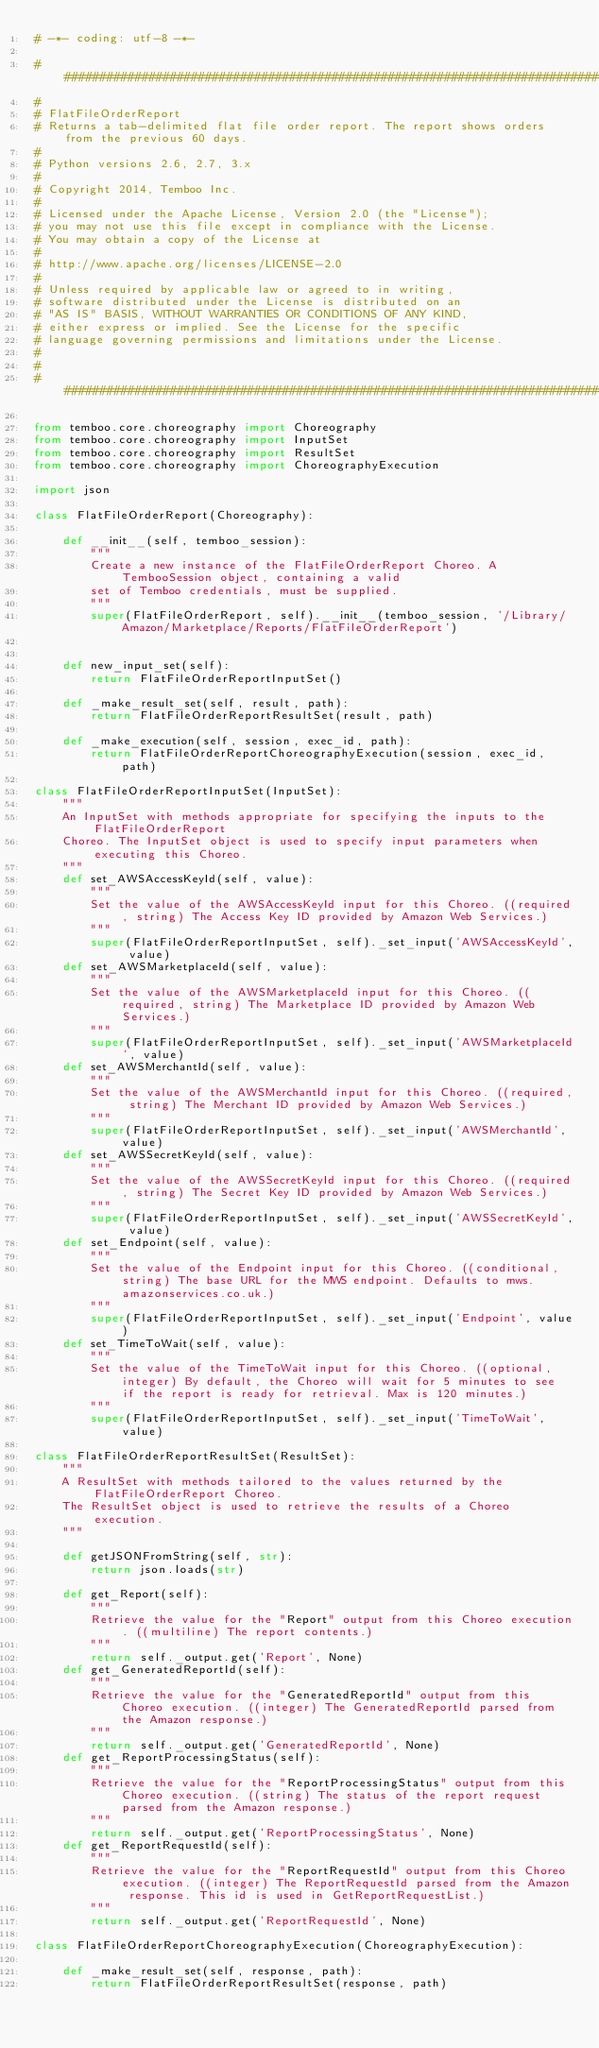Convert code to text. <code><loc_0><loc_0><loc_500><loc_500><_Python_># -*- coding: utf-8 -*-

###############################################################################
#
# FlatFileOrderReport
# Returns a tab-delimited flat file order report. The report shows orders from the previous 60 days.
#
# Python versions 2.6, 2.7, 3.x
#
# Copyright 2014, Temboo Inc.
#
# Licensed under the Apache License, Version 2.0 (the "License");
# you may not use this file except in compliance with the License.
# You may obtain a copy of the License at
#
# http://www.apache.org/licenses/LICENSE-2.0
#
# Unless required by applicable law or agreed to in writing,
# software distributed under the License is distributed on an
# "AS IS" BASIS, WITHOUT WARRANTIES OR CONDITIONS OF ANY KIND,
# either express or implied. See the License for the specific
# language governing permissions and limitations under the License.
#
#
###############################################################################

from temboo.core.choreography import Choreography
from temboo.core.choreography import InputSet
from temboo.core.choreography import ResultSet
from temboo.core.choreography import ChoreographyExecution

import json

class FlatFileOrderReport(Choreography):

    def __init__(self, temboo_session):
        """
        Create a new instance of the FlatFileOrderReport Choreo. A TembooSession object, containing a valid
        set of Temboo credentials, must be supplied.
        """
        super(FlatFileOrderReport, self).__init__(temboo_session, '/Library/Amazon/Marketplace/Reports/FlatFileOrderReport')


    def new_input_set(self):
        return FlatFileOrderReportInputSet()

    def _make_result_set(self, result, path):
        return FlatFileOrderReportResultSet(result, path)

    def _make_execution(self, session, exec_id, path):
        return FlatFileOrderReportChoreographyExecution(session, exec_id, path)

class FlatFileOrderReportInputSet(InputSet):
    """
    An InputSet with methods appropriate for specifying the inputs to the FlatFileOrderReport
    Choreo. The InputSet object is used to specify input parameters when executing this Choreo.
    """
    def set_AWSAccessKeyId(self, value):
        """
        Set the value of the AWSAccessKeyId input for this Choreo. ((required, string) The Access Key ID provided by Amazon Web Services.)
        """
        super(FlatFileOrderReportInputSet, self)._set_input('AWSAccessKeyId', value)
    def set_AWSMarketplaceId(self, value):
        """
        Set the value of the AWSMarketplaceId input for this Choreo. ((required, string) The Marketplace ID provided by Amazon Web Services.)
        """
        super(FlatFileOrderReportInputSet, self)._set_input('AWSMarketplaceId', value)
    def set_AWSMerchantId(self, value):
        """
        Set the value of the AWSMerchantId input for this Choreo. ((required, string) The Merchant ID provided by Amazon Web Services.)
        """
        super(FlatFileOrderReportInputSet, self)._set_input('AWSMerchantId', value)
    def set_AWSSecretKeyId(self, value):
        """
        Set the value of the AWSSecretKeyId input for this Choreo. ((required, string) The Secret Key ID provided by Amazon Web Services.)
        """
        super(FlatFileOrderReportInputSet, self)._set_input('AWSSecretKeyId', value)
    def set_Endpoint(self, value):
        """
        Set the value of the Endpoint input for this Choreo. ((conditional, string) The base URL for the MWS endpoint. Defaults to mws.amazonservices.co.uk.)
        """
        super(FlatFileOrderReportInputSet, self)._set_input('Endpoint', value)
    def set_TimeToWait(self, value):
        """
        Set the value of the TimeToWait input for this Choreo. ((optional, integer) By default, the Choreo will wait for 5 minutes to see if the report is ready for retrieval. Max is 120 minutes.)
        """
        super(FlatFileOrderReportInputSet, self)._set_input('TimeToWait', value)

class FlatFileOrderReportResultSet(ResultSet):
    """
    A ResultSet with methods tailored to the values returned by the FlatFileOrderReport Choreo.
    The ResultSet object is used to retrieve the results of a Choreo execution.
    """

    def getJSONFromString(self, str):
        return json.loads(str)

    def get_Report(self):
        """
        Retrieve the value for the "Report" output from this Choreo execution. ((multiline) The report contents.)
        """
        return self._output.get('Report', None)
    def get_GeneratedReportId(self):
        """
        Retrieve the value for the "GeneratedReportId" output from this Choreo execution. ((integer) The GeneratedReportId parsed from the Amazon response.)
        """
        return self._output.get('GeneratedReportId', None)
    def get_ReportProcessingStatus(self):
        """
        Retrieve the value for the "ReportProcessingStatus" output from this Choreo execution. ((string) The status of the report request parsed from the Amazon response.)
        """
        return self._output.get('ReportProcessingStatus', None)
    def get_ReportRequestId(self):
        """
        Retrieve the value for the "ReportRequestId" output from this Choreo execution. ((integer) The ReportRequestId parsed from the Amazon response. This id is used in GetReportRequestList.)
        """
        return self._output.get('ReportRequestId', None)

class FlatFileOrderReportChoreographyExecution(ChoreographyExecution):

    def _make_result_set(self, response, path):
        return FlatFileOrderReportResultSet(response, path)
</code> 